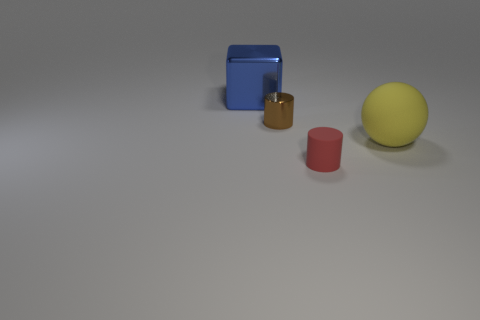Add 1 tiny objects. How many objects exist? 5 Subtract all cubes. How many objects are left? 3 Subtract all purple shiny things. Subtract all small shiny things. How many objects are left? 3 Add 4 big blue metal cubes. How many big blue metal cubes are left? 5 Add 3 tiny things. How many tiny things exist? 5 Subtract 0 cyan balls. How many objects are left? 4 